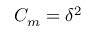Convert formula to latex. <formula><loc_0><loc_0><loc_500><loc_500>C _ { m } = \delta ^ { 2 }</formula> 